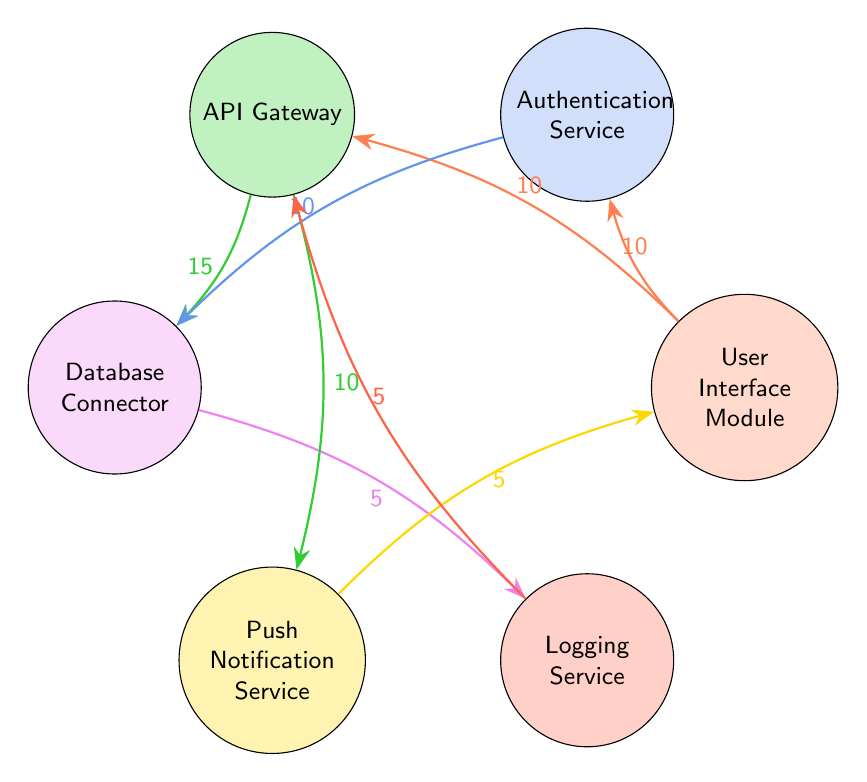What is the total number of modules in the diagram? The diagram lists six different modules: User Interface Module, Authentication Service, API Gateway, Database Connector, Push Notification Service, and Logging Service. Counting these gives a total of six modules.
Answer: six What is the value of the connection from the User Interface Module to the Authentication Service? The diagram indicates a connection from the User Interface Module to the Authentication Service with a value of 10.
Answer: 10 How many modules directly communicate with the API Gateway? The API Gateway has two direct connections: one with the Database Connector (value 15) and one with the Push Notification Service (value 10). This makes a total of two modules directly communicating with the API Gateway.
Answer: two Which module receives a value of 5 from the Push Notification Service? The Push Notification Service connects to the User Interface Module with a value of 5. This indicates that the User Interface Module is the recipient of this connection.
Answer: User Interface Module What is the combined value of connections leading to the Database Connector? There are two connections leading to the Database Connector: one from the API Gateway valued at 15 and another from the Authentication Service valued at 10. Adding these values gives a total of 25.
Answer: 25 What is the flow of data from the User Interface Module to the Logging Service? The data flows from the User Interface Module to the Authentication Service (10), then to the Database Connector (10), which subsequently connects to the Logging Service (5). The total flow of values leads to the Logging Service through these connections.
Answer: 5 Which module sends push notifications? The module that sends push notifications is the Push Notification Service, as indicated by its connections in the diagram.
Answer: Push Notification Service What is the value of the connection from the Logging Service back to the API Gateway? The diagram shows a connection from the Logging Service to the API Gateway with a value of 5, indicating the amount of data flowing back to the API Gateway.
Answer: 5 What can be inferred about the User Interface Module's role in the data flow? The User Interface Module initiates data flow by connecting to both the Authentication Service and the API Gateway with equal values of 10, suggesting it plays a crucial role in user interaction and communication with backend services.
Answer: initiator 